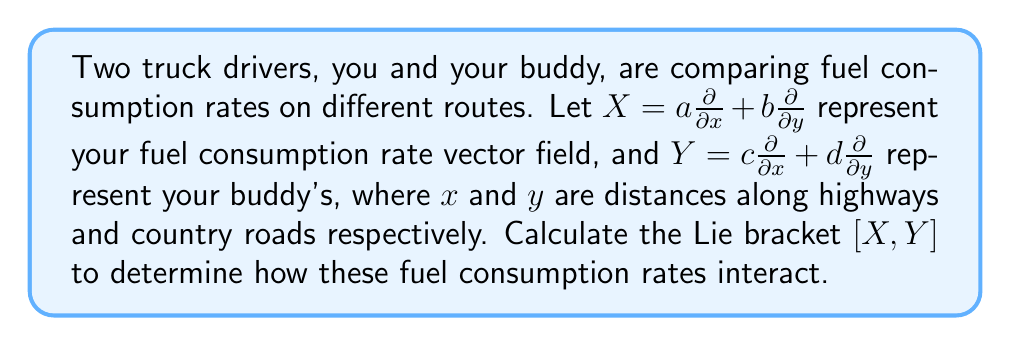Can you answer this question? To solve this problem, we need to follow these steps:

1) Recall the formula for the Lie bracket of two vector fields $X$ and $Y$:

   $$[X,Y] = XY - YX$$

2) Expand $X$ and $Y$:
   
   $X = a\frac{\partial}{\partial x} + b\frac{\partial}{\partial y}$
   $Y = c\frac{\partial}{\partial x} + d\frac{\partial}{\partial y}$

3) Calculate $XY$:
   
   $$XY = (a\frac{\partial}{\partial x} + b\frac{\partial}{\partial y})(c\frac{\partial}{\partial x} + d\frac{\partial}{\partial y})$$
   
   $$= ac\frac{\partial^2}{\partial x^2} + ad\frac{\partial^2}{\partial x\partial y} + bc\frac{\partial^2}{\partial y\partial x} + bd\frac{\partial^2}{\partial y^2}$$
   
   $$+ a(\frac{\partial c}{\partial x}\frac{\partial}{\partial x} + \frac{\partial d}{\partial x}\frac{\partial}{\partial y}) + b(\frac{\partial c}{\partial y}\frac{\partial}{\partial x} + \frac{\partial d}{\partial y}\frac{\partial}{\partial y})$$

4) Calculate $YX$:
   
   $$YX = (c\frac{\partial}{\partial x} + d\frac{\partial}{\partial y})(a\frac{\partial}{\partial x} + b\frac{\partial}{\partial y})$$
   
   $$= ca\frac{\partial^2}{\partial x^2} + cb\frac{\partial^2}{\partial x\partial y} + da\frac{\partial^2}{\partial y\partial x} + db\frac{\partial^2}{\partial y^2}$$
   
   $$+ c(\frac{\partial a}{\partial x}\frac{\partial}{\partial x} + \frac{\partial b}{\partial x}\frac{\partial}{\partial y}) + d(\frac{\partial a}{\partial y}\frac{\partial}{\partial x} + \frac{\partial b}{\partial y}\frac{\partial}{\partial y})$$

5) Subtract $YX$ from $XY$:

   $$[X,Y] = XY - YX$$
   
   $$= (a\frac{\partial c}{\partial x} - c\frac{\partial a}{\partial x} + b\frac{\partial c}{\partial y} - d\frac{\partial a}{\partial y})\frac{\partial}{\partial x} + (a\frac{\partial d}{\partial x} - c\frac{\partial b}{\partial x} + b\frac{\partial d}{\partial y} - d\frac{\partial b}{\partial y})\frac{\partial}{\partial y}$$

This is the Lie bracket $[X,Y]$ of the two vector fields representing fuel consumption rates.
Answer: $$[X,Y] = (a\frac{\partial c}{\partial x} - c\frac{\partial a}{\partial x} + b\frac{\partial c}{\partial y} - d\frac{\partial a}{\partial y})\frac{\partial}{\partial x} + (a\frac{\partial d}{\partial x} - c\frac{\partial b}{\partial x} + b\frac{\partial d}{\partial y} - d\frac{\partial b}{\partial y})\frac{\partial}{\partial y}$$ 